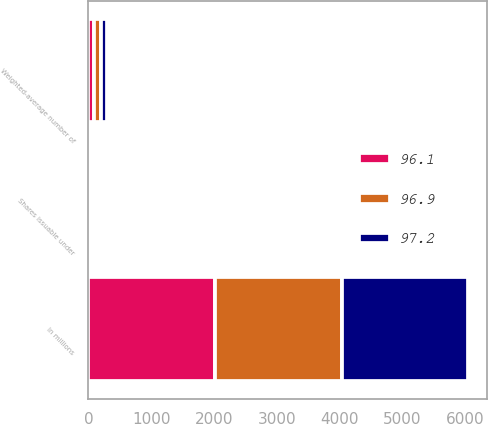Convert chart to OTSL. <chart><loc_0><loc_0><loc_500><loc_500><stacked_bar_chart><ecel><fcel>In millions<fcel>Weighted-average number of<fcel>Shares issuable under<nl><fcel>96.9<fcel>2015<fcel>96.9<fcel>1<nl><fcel>96.1<fcel>2014<fcel>97.2<fcel>1.1<nl><fcel>97.2<fcel>2013<fcel>96.1<fcel>0.1<nl></chart> 